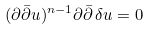Convert formula to latex. <formula><loc_0><loc_0><loc_500><loc_500>( \partial \bar { \partial } u ) ^ { n - 1 } \partial \bar { \partial } \, \delta u = 0</formula> 